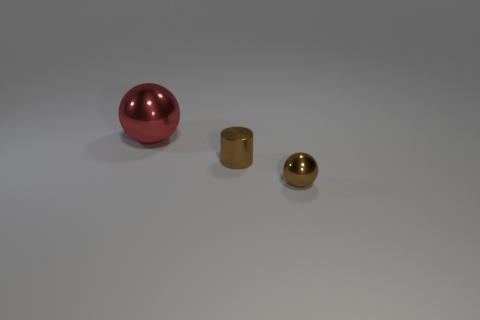Add 1 metal things. How many objects exist? 4 Subtract all red balls. How many balls are left? 1 Subtract all balls. How many objects are left? 1 Subtract 2 spheres. How many spheres are left? 0 Subtract all green cylinders. Subtract all purple cubes. How many cylinders are left? 1 Subtract all yellow cubes. How many red cylinders are left? 0 Subtract all metal objects. Subtract all tiny cyan objects. How many objects are left? 0 Add 1 large red balls. How many large red balls are left? 2 Add 1 big blue metal blocks. How many big blue metal blocks exist? 1 Subtract 0 cyan cubes. How many objects are left? 3 